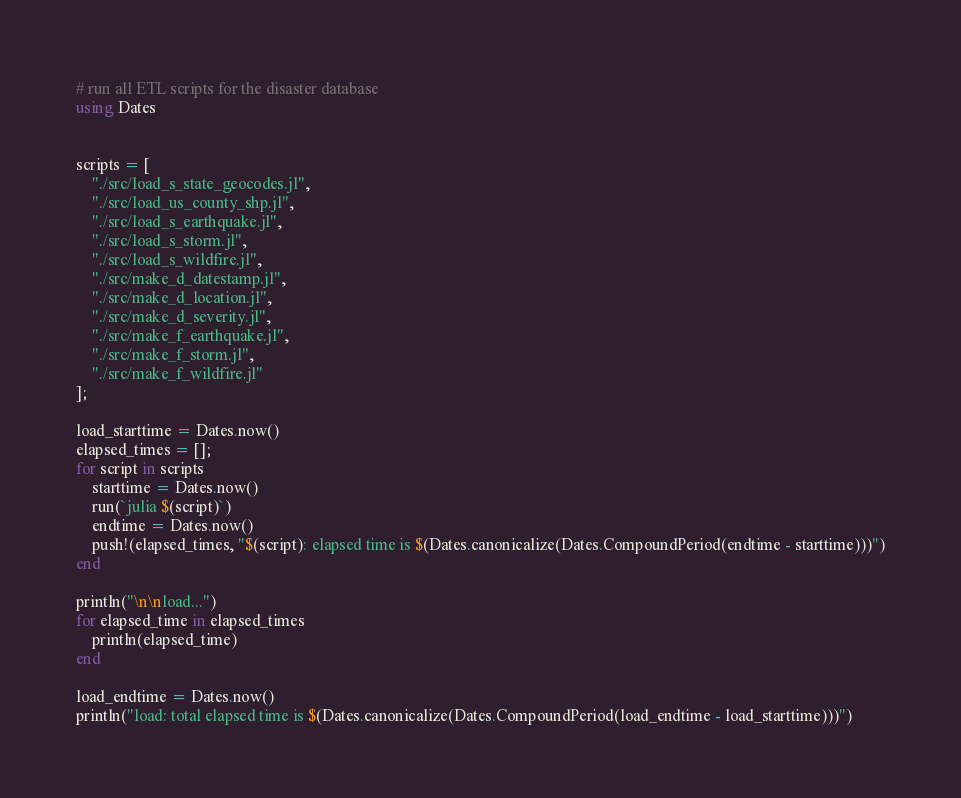Convert code to text. <code><loc_0><loc_0><loc_500><loc_500><_Julia_># run all ETL scripts for the disaster database
using Dates


scripts = [
    "./src/load_s_state_geocodes.jl",
    "./src/load_us_county_shp.jl",
    "./src/load_s_earthquake.jl",
    "./src/load_s_storm.jl",
    "./src/load_s_wildfire.jl",
    "./src/make_d_datestamp.jl",
    "./src/make_d_location.jl",
    "./src/make_d_severity.jl",
    "./src/make_f_earthquake.jl",
    "./src/make_f_storm.jl",
    "./src/make_f_wildfire.jl"
];

load_starttime = Dates.now()
elapsed_times = [];
for script in scripts
    starttime = Dates.now()
    run(`julia $(script)`)
    endtime = Dates.now()
    push!(elapsed_times, "$(script): elapsed time is $(Dates.canonicalize(Dates.CompoundPeriod(endtime - starttime)))")
end

println("\n\nload...")
for elapsed_time in elapsed_times
    println(elapsed_time)
end

load_endtime = Dates.now()
println("load: total elapsed time is $(Dates.canonicalize(Dates.CompoundPeriod(load_endtime - load_starttime)))")
</code> 